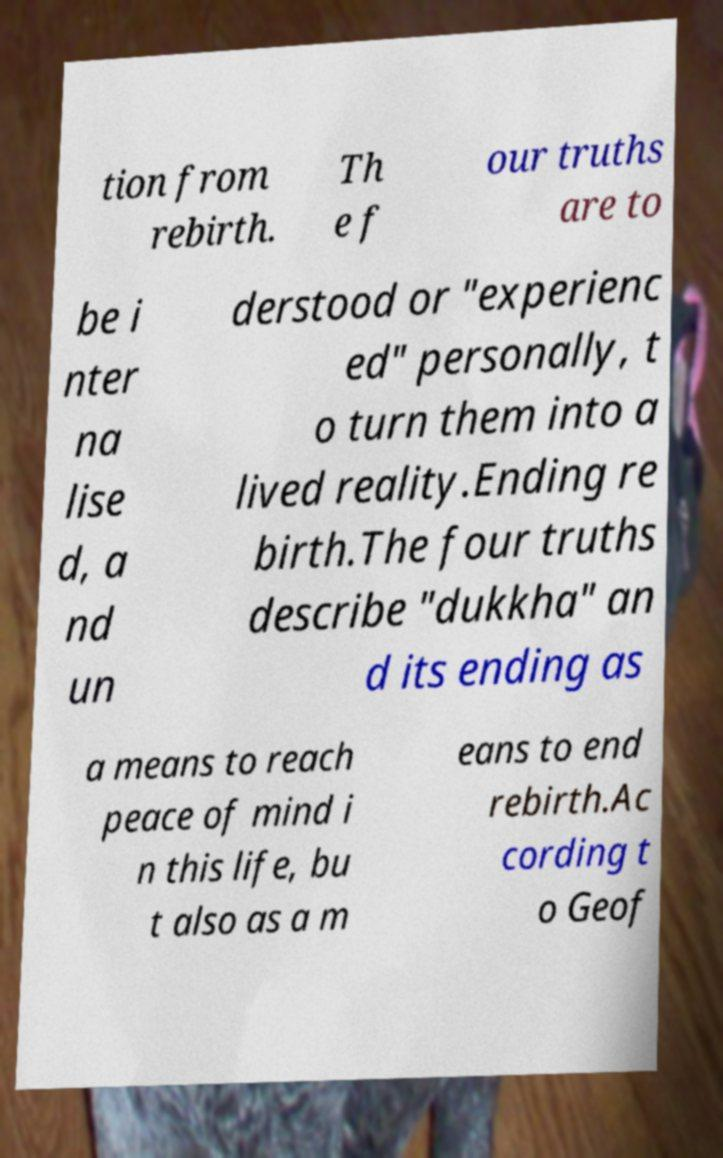Could you extract and type out the text from this image? tion from rebirth. Th e f our truths are to be i nter na lise d, a nd un derstood or "experienc ed" personally, t o turn them into a lived reality.Ending re birth.The four truths describe "dukkha" an d its ending as a means to reach peace of mind i n this life, bu t also as a m eans to end rebirth.Ac cording t o Geof 